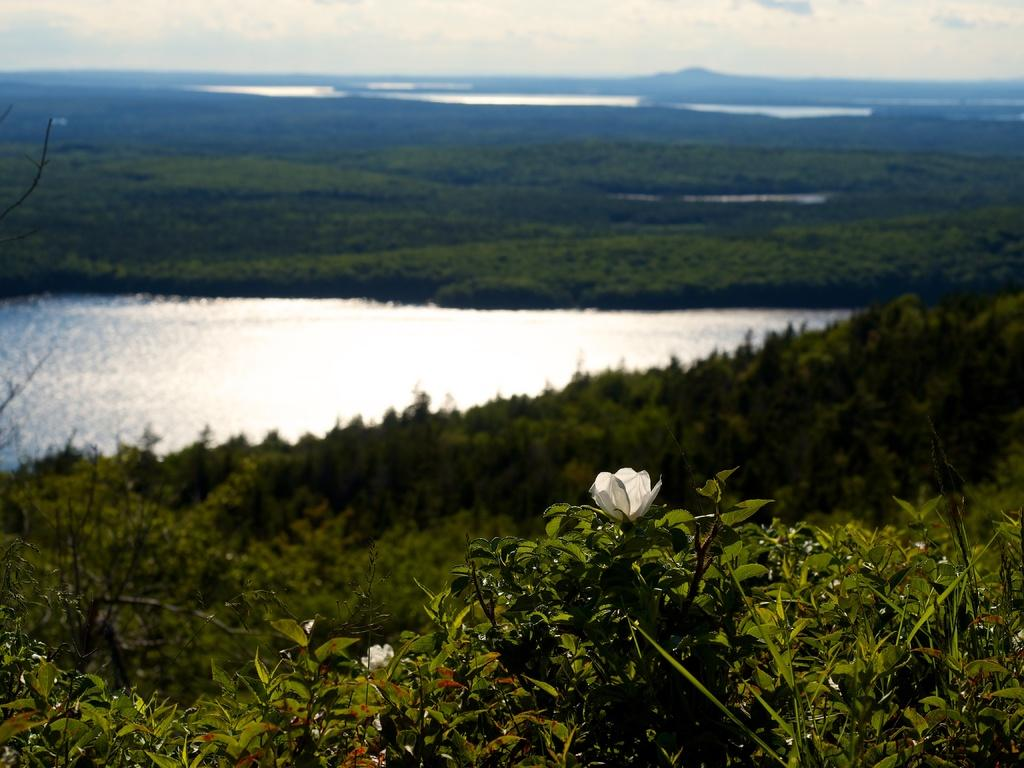What type of living organisms can be seen in the image? Plants are visible in the image. Can you describe a specific type of flower in the image? There is a white flower in the image. What is the primary element visible in the image? Water is visible in the image. What part of the natural environment can be seen in the image? The sky is visible in the image. What is your brother writing about in the image? There is no reference to a brother or any writing in the image, so it's not possible to answer that question. 